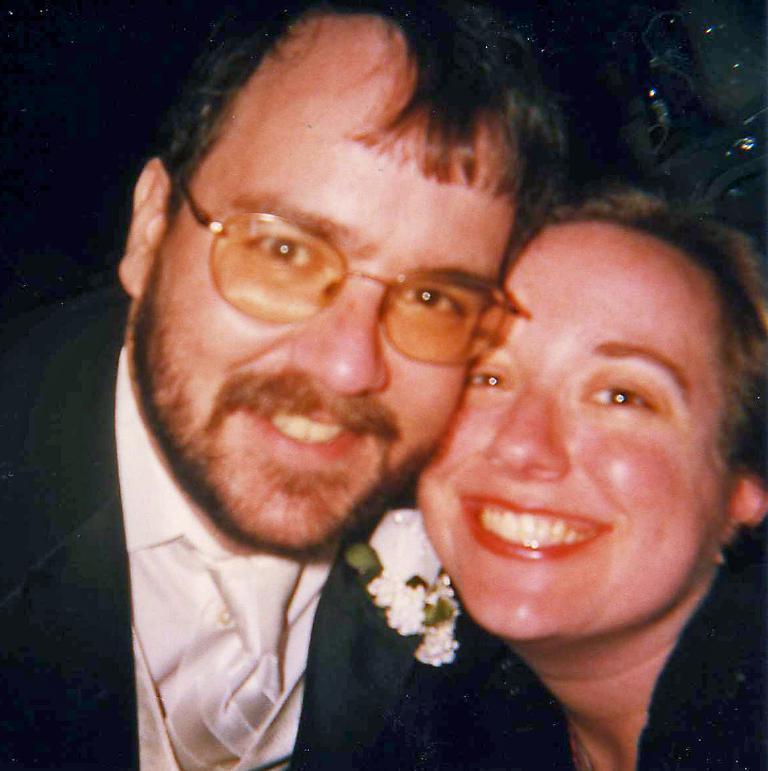Describe this image in one or two sentences. In this picture we can see a woman, man wore spectacles and they both are smiling and in the background it is dark. 